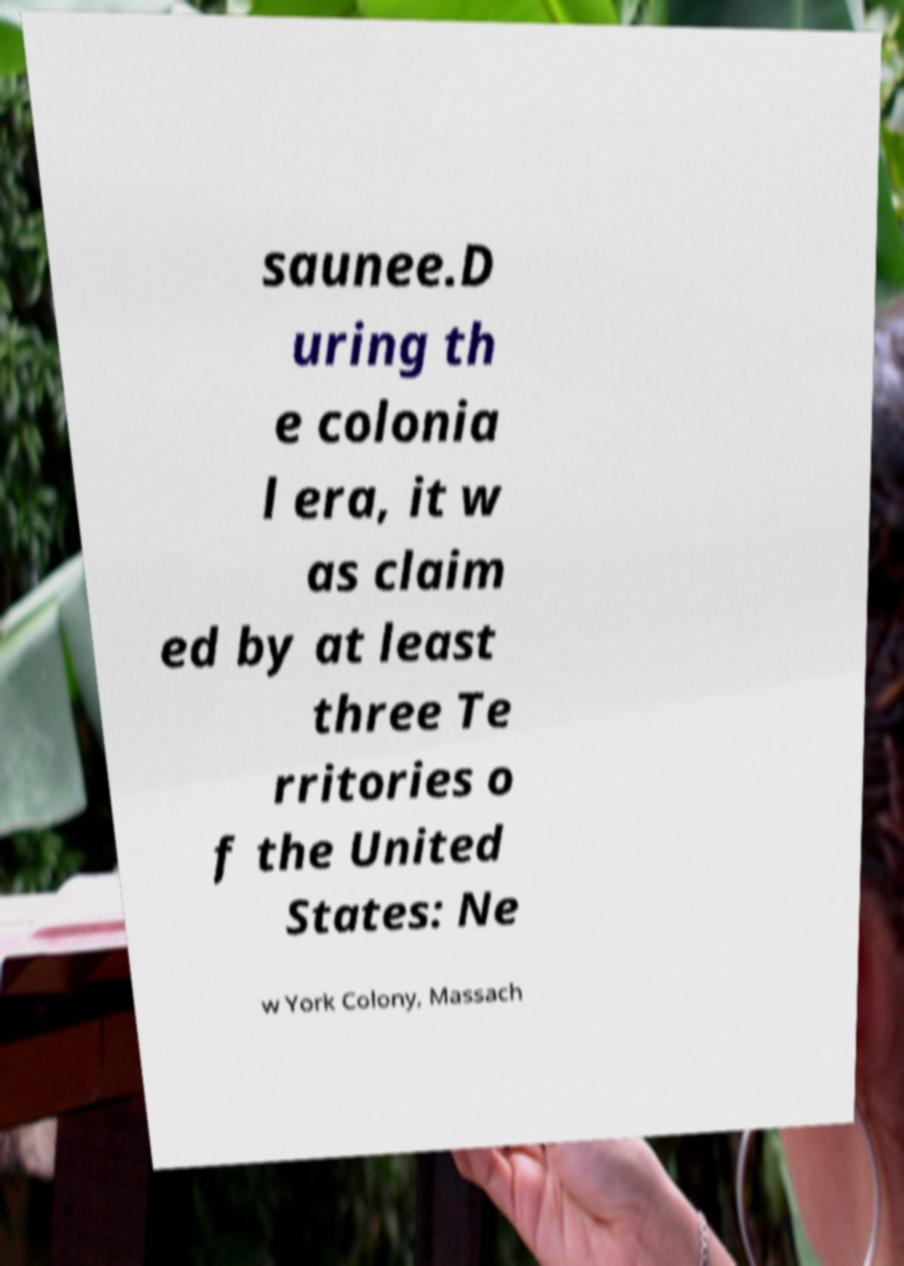Please read and relay the text visible in this image. What does it say? saunee.D uring th e colonia l era, it w as claim ed by at least three Te rritories o f the United States: Ne w York Colony, Massach 